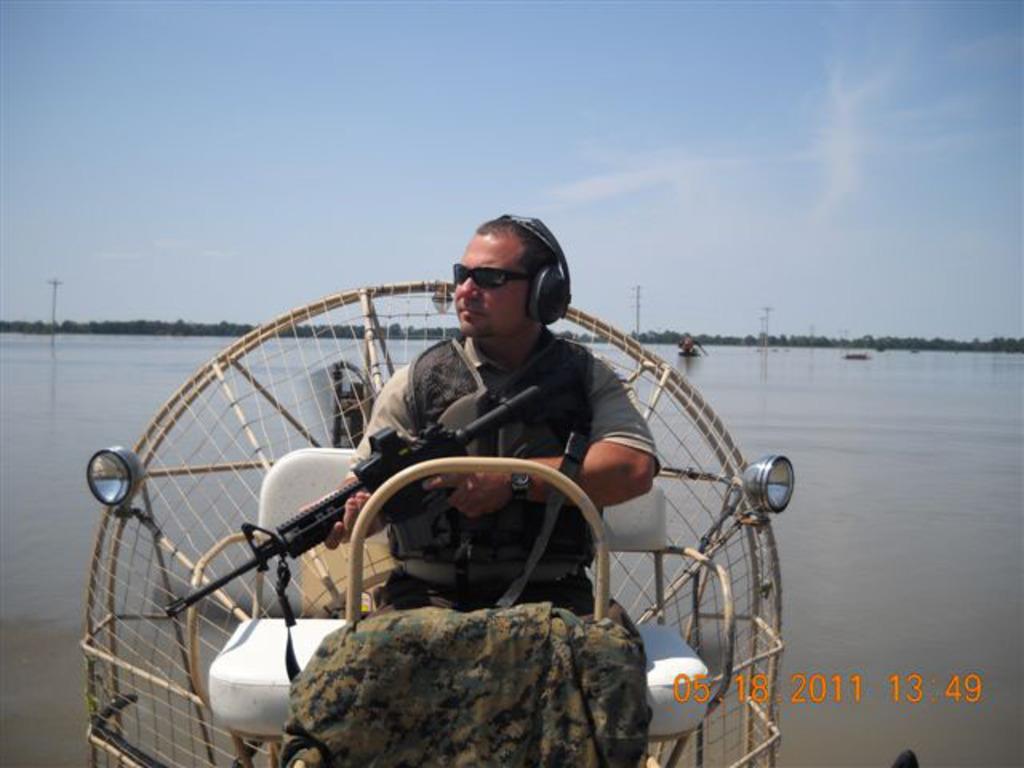How would you summarize this image in a sentence or two? In this image I can see a person wearing goggles, headphones and dress is sitting and holding a gun in his hands. I can see he is on the boat. In the background I can see the water, few objects on the surface of the water, few trees, few poles and the sky. 